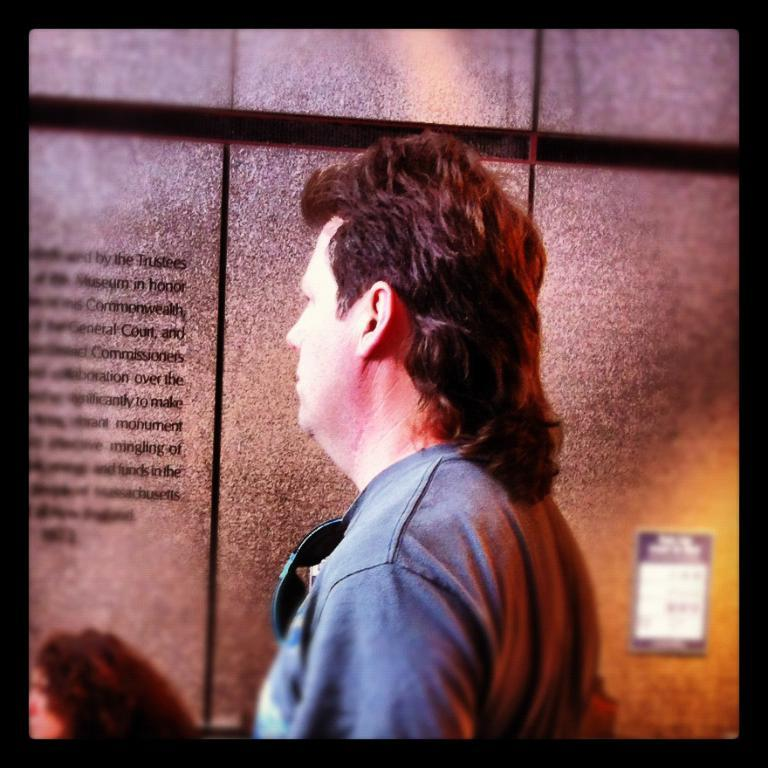Who is present in the image? There is a man in the image. What is the man wearing? The man is wearing a blue T-shirt. What can be seen on the wall beside the man? There is a frame on the wall beside the man. What type of whip is the man holding in the image? There is no whip present in the image; the man is not holding any object. 